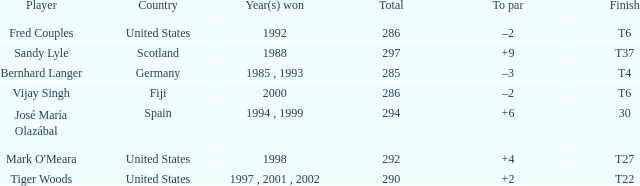Which player has +2 to par? Tiger Woods. 